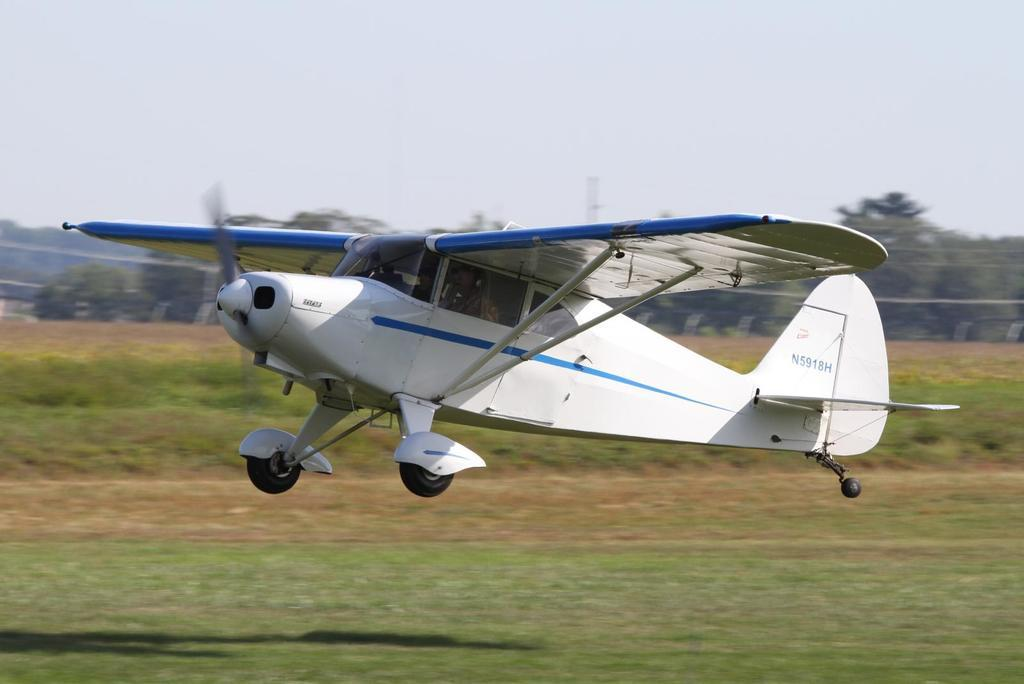What is flying in the air in the image? There is a jet plane flying in the air in the image. What type of landscape can be seen in the image? There are grass fields visible in the image. Are there any other natural elements present in the image? Yes, there are trees present in the image. Can you see a boat sailing on the grass fields in the image? No, there is no boat present in the image; it features a jet plane flying in the air and grass fields. What type of cake is being served on the trees in the image? There is no cake present in the image; it features a jet plane flying in the air, grass fields, and trees. 